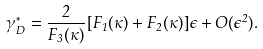Convert formula to latex. <formula><loc_0><loc_0><loc_500><loc_500>\gamma ^ { * } _ { D } = \frac { 2 } { F _ { 3 } ( \kappa ) } [ F _ { 1 } ( \kappa ) + F _ { 2 } ( \kappa ) ] \epsilon + O ( \epsilon ^ { 2 } ) .</formula> 